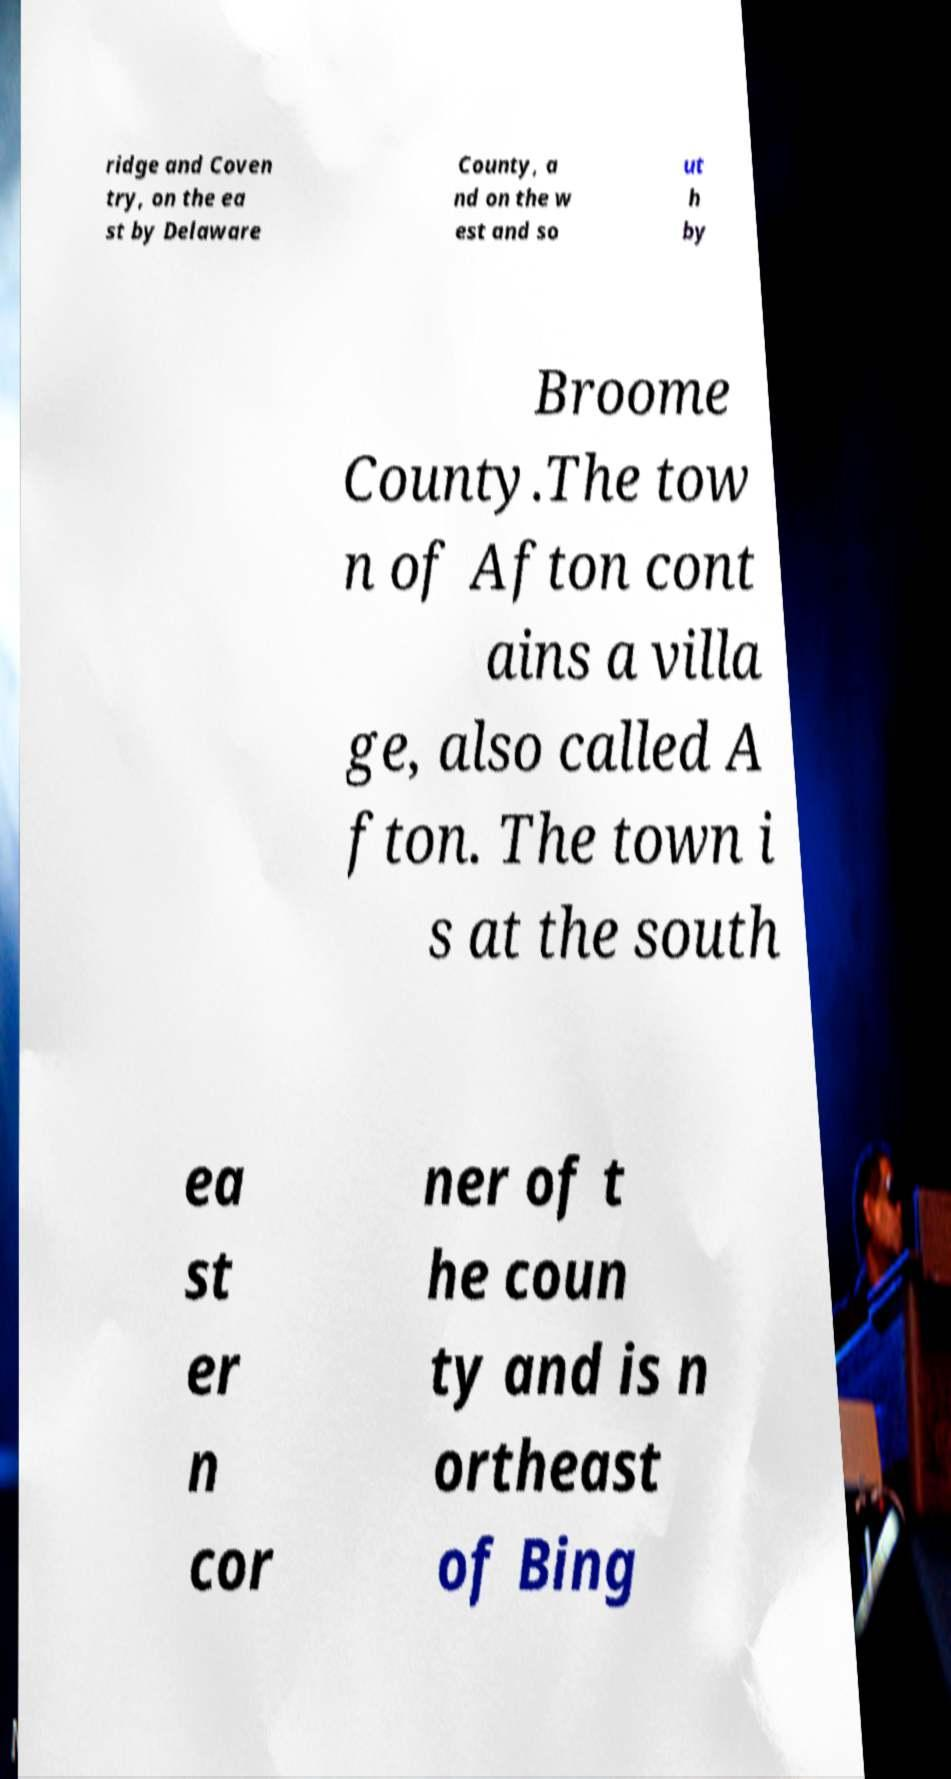Please read and relay the text visible in this image. What does it say? ridge and Coven try, on the ea st by Delaware County, a nd on the w est and so ut h by Broome County.The tow n of Afton cont ains a villa ge, also called A fton. The town i s at the south ea st er n cor ner of t he coun ty and is n ortheast of Bing 